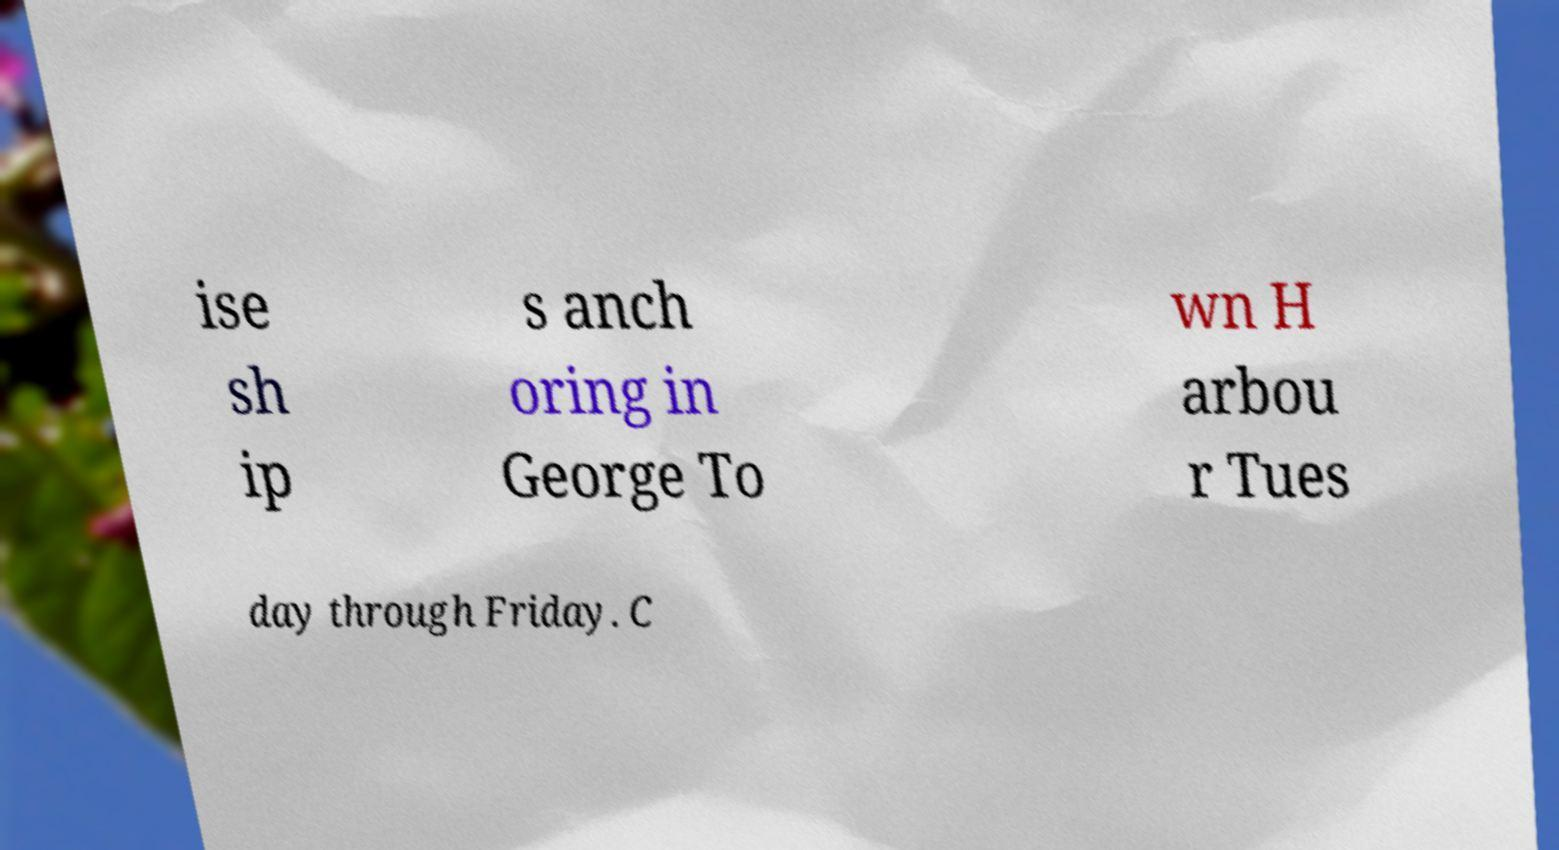For documentation purposes, I need the text within this image transcribed. Could you provide that? ise sh ip s anch oring in George To wn H arbou r Tues day through Friday. C 